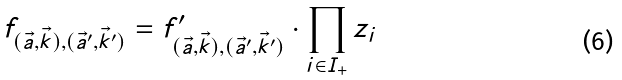Convert formula to latex. <formula><loc_0><loc_0><loc_500><loc_500>f _ { ( \vec { a } , \vec { k } ) , ( \vec { a } ^ { \prime } , \vec { k } ^ { \prime } ) } = f _ { ( \vec { a } , \vec { k } ) , ( \vec { a } ^ { \prime } , \vec { k } ^ { \prime } ) } ^ { \prime } \cdot \prod _ { i \in I _ { + } } z _ { i }</formula> 